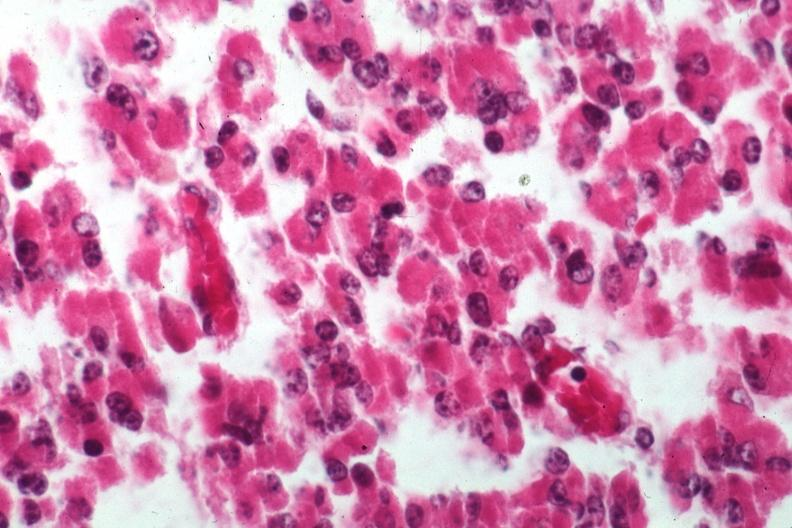s hematoma present?
Answer the question using a single word or phrase. No 